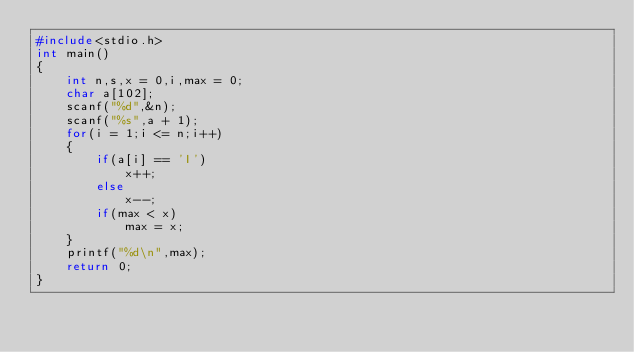<code> <loc_0><loc_0><loc_500><loc_500><_C_>#include<stdio.h>
int main()
{
	int n,s,x = 0,i,max = 0;
	char a[102];
	scanf("%d",&n);
	scanf("%s",a + 1);
	for(i = 1;i <= n;i++)
	{
		if(a[i] == 'I')
			x++;
		else
			x--;
		if(max < x)
			max = x;
	}
	printf("%d\n",max);
	return 0;
}

</code> 